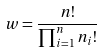<formula> <loc_0><loc_0><loc_500><loc_500>w = \frac { n ! } { \prod _ { i = 1 } ^ { n } n _ { i } ! }</formula> 